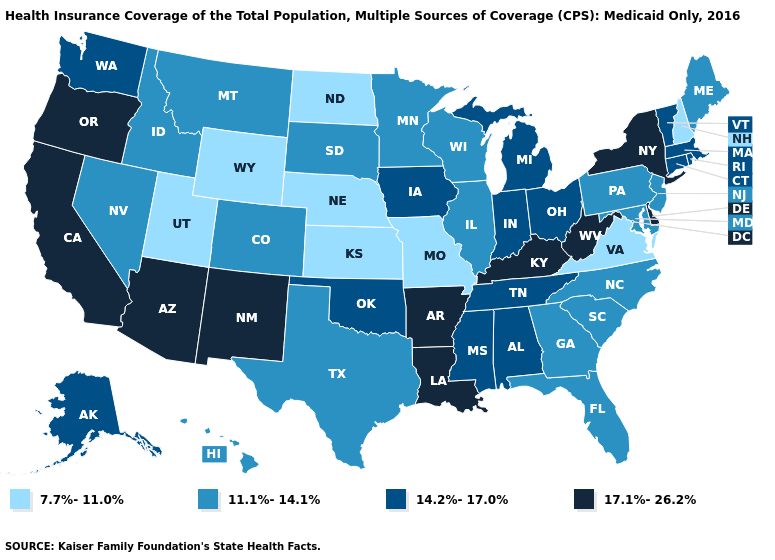Does New Mexico have the highest value in the West?
Keep it brief. Yes. What is the lowest value in the USA?
Concise answer only. 7.7%-11.0%. Name the states that have a value in the range 11.1%-14.1%?
Short answer required. Colorado, Florida, Georgia, Hawaii, Idaho, Illinois, Maine, Maryland, Minnesota, Montana, Nevada, New Jersey, North Carolina, Pennsylvania, South Carolina, South Dakota, Texas, Wisconsin. Does the map have missing data?
Concise answer only. No. Does the first symbol in the legend represent the smallest category?
Answer briefly. Yes. Does Maine have a lower value than Montana?
Write a very short answer. No. What is the highest value in the Northeast ?
Be succinct. 17.1%-26.2%. How many symbols are there in the legend?
Short answer required. 4. What is the lowest value in the West?
Write a very short answer. 7.7%-11.0%. Name the states that have a value in the range 7.7%-11.0%?
Be succinct. Kansas, Missouri, Nebraska, New Hampshire, North Dakota, Utah, Virginia, Wyoming. What is the highest value in states that border Maine?
Concise answer only. 7.7%-11.0%. What is the value of Michigan?
Answer briefly. 14.2%-17.0%. What is the value of Florida?
Concise answer only. 11.1%-14.1%. What is the lowest value in the USA?
Short answer required. 7.7%-11.0%. 